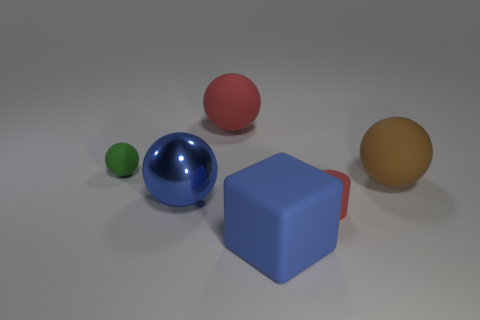What color is the metal object?
Your response must be concise. Blue. The tiny sphere that is the same material as the big block is what color?
Keep it short and to the point. Green. What number of small green spheres have the same material as the green thing?
Offer a very short reply. 0. There is a small red object; what number of green things are to the left of it?
Provide a succinct answer. 1. Are the big red sphere behind the small green matte thing and the large blue thing in front of the tiny cylinder made of the same material?
Ensure brevity in your answer.  Yes. Are there more big brown rubber things to the right of the tiny cylinder than small red things behind the small green rubber thing?
Your response must be concise. Yes. What is the material of the big cube that is the same color as the big metal object?
Give a very brief answer. Rubber. Is there anything else that is the same shape as the large blue matte thing?
Ensure brevity in your answer.  No. The thing that is both to the left of the big brown rubber thing and to the right of the rubber cube is made of what material?
Provide a succinct answer. Rubber. Does the small ball have the same material as the large ball behind the tiny green rubber object?
Offer a very short reply. Yes. 